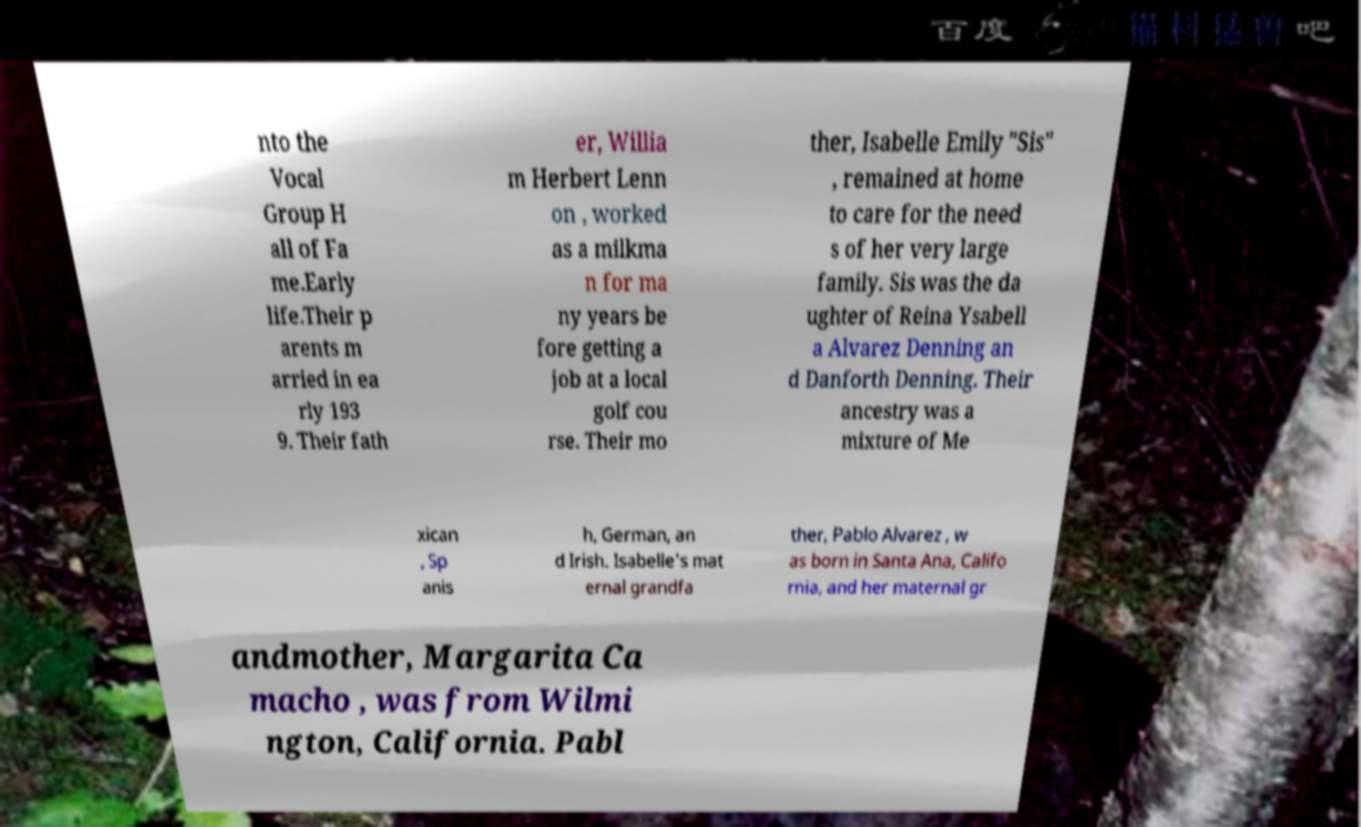For documentation purposes, I need the text within this image transcribed. Could you provide that? nto the Vocal Group H all of Fa me.Early life.Their p arents m arried in ea rly 193 9. Their fath er, Willia m Herbert Lenn on , worked as a milkma n for ma ny years be fore getting a job at a local golf cou rse. Their mo ther, Isabelle Emily "Sis" , remained at home to care for the need s of her very large family. Sis was the da ughter of Reina Ysabell a Alvarez Denning an d Danforth Denning. Their ancestry was a mixture of Me xican , Sp anis h, German, an d Irish. Isabelle's mat ernal grandfa ther, Pablo Alvarez , w as born in Santa Ana, Califo rnia, and her maternal gr andmother, Margarita Ca macho , was from Wilmi ngton, California. Pabl 